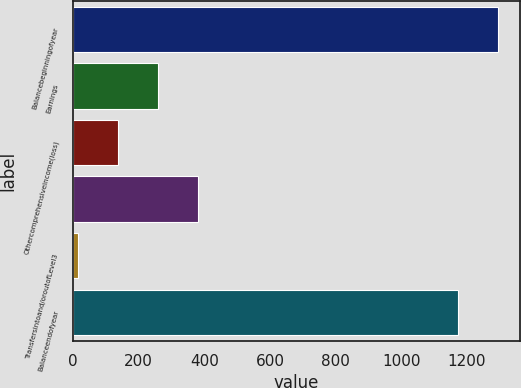Convert chart to OTSL. <chart><loc_0><loc_0><loc_500><loc_500><bar_chart><fcel>Balancebeginningofyear<fcel>Earnings<fcel>Othercomprehensiveincome(loss)<fcel>Unnamed: 3<fcel>Transfersintoand/oroutofLevel3<fcel>Balanceendofyear<nl><fcel>1295.5<fcel>260<fcel>137.5<fcel>382.5<fcel>15<fcel>1173<nl></chart> 